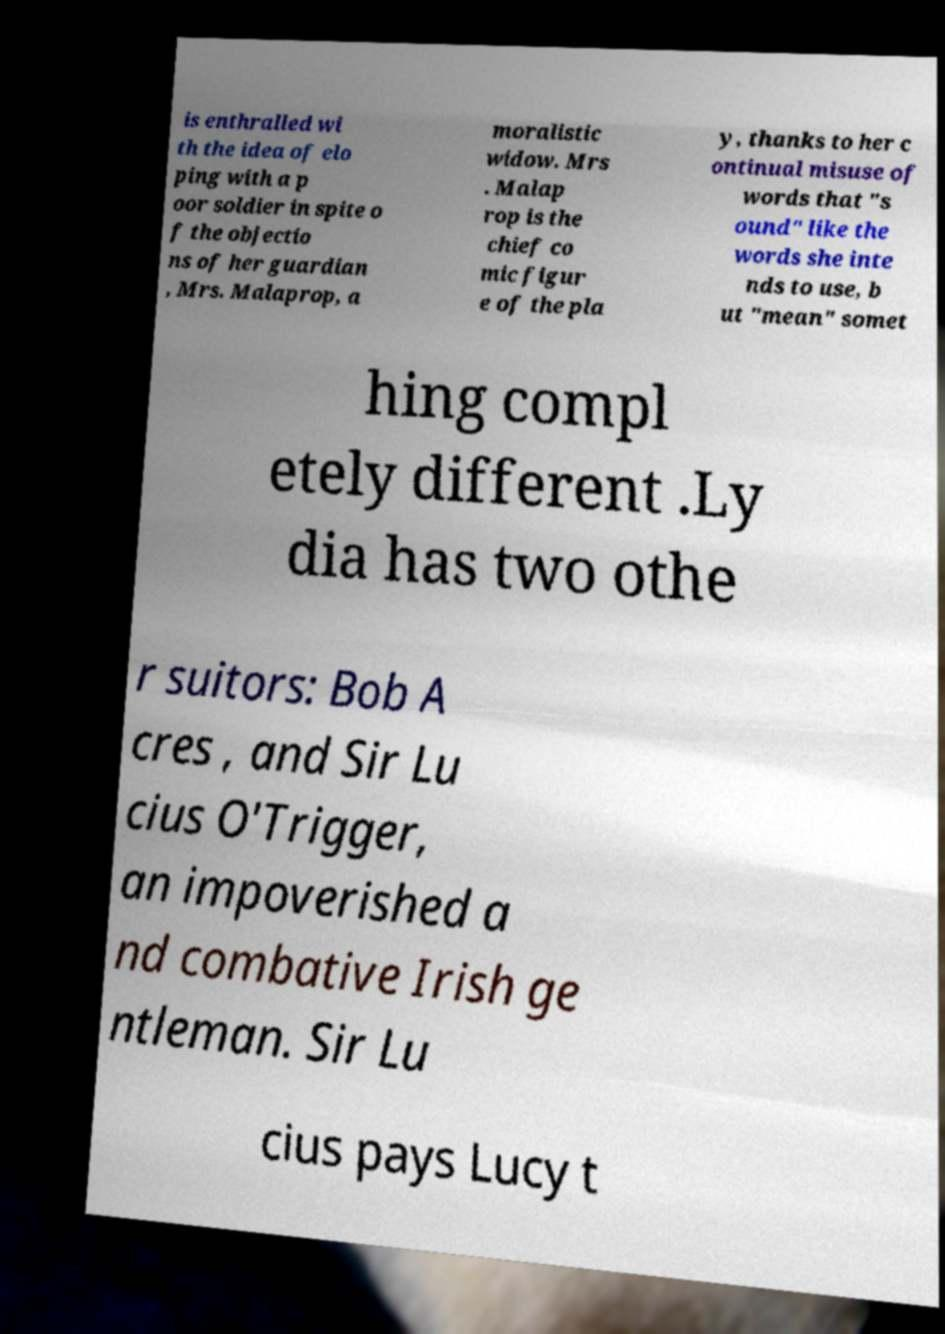Can you read and provide the text displayed in the image?This photo seems to have some interesting text. Can you extract and type it out for me? is enthralled wi th the idea of elo ping with a p oor soldier in spite o f the objectio ns of her guardian , Mrs. Malaprop, a moralistic widow. Mrs . Malap rop is the chief co mic figur e of the pla y, thanks to her c ontinual misuse of words that "s ound" like the words she inte nds to use, b ut "mean" somet hing compl etely different .Ly dia has two othe r suitors: Bob A cres , and Sir Lu cius O'Trigger, an impoverished a nd combative Irish ge ntleman. Sir Lu cius pays Lucy t 